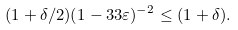Convert formula to latex. <formula><loc_0><loc_0><loc_500><loc_500>( 1 + \delta / 2 ) ( 1 - 3 3 \varepsilon ) ^ { - 2 } \leq ( 1 + \delta ) .</formula> 